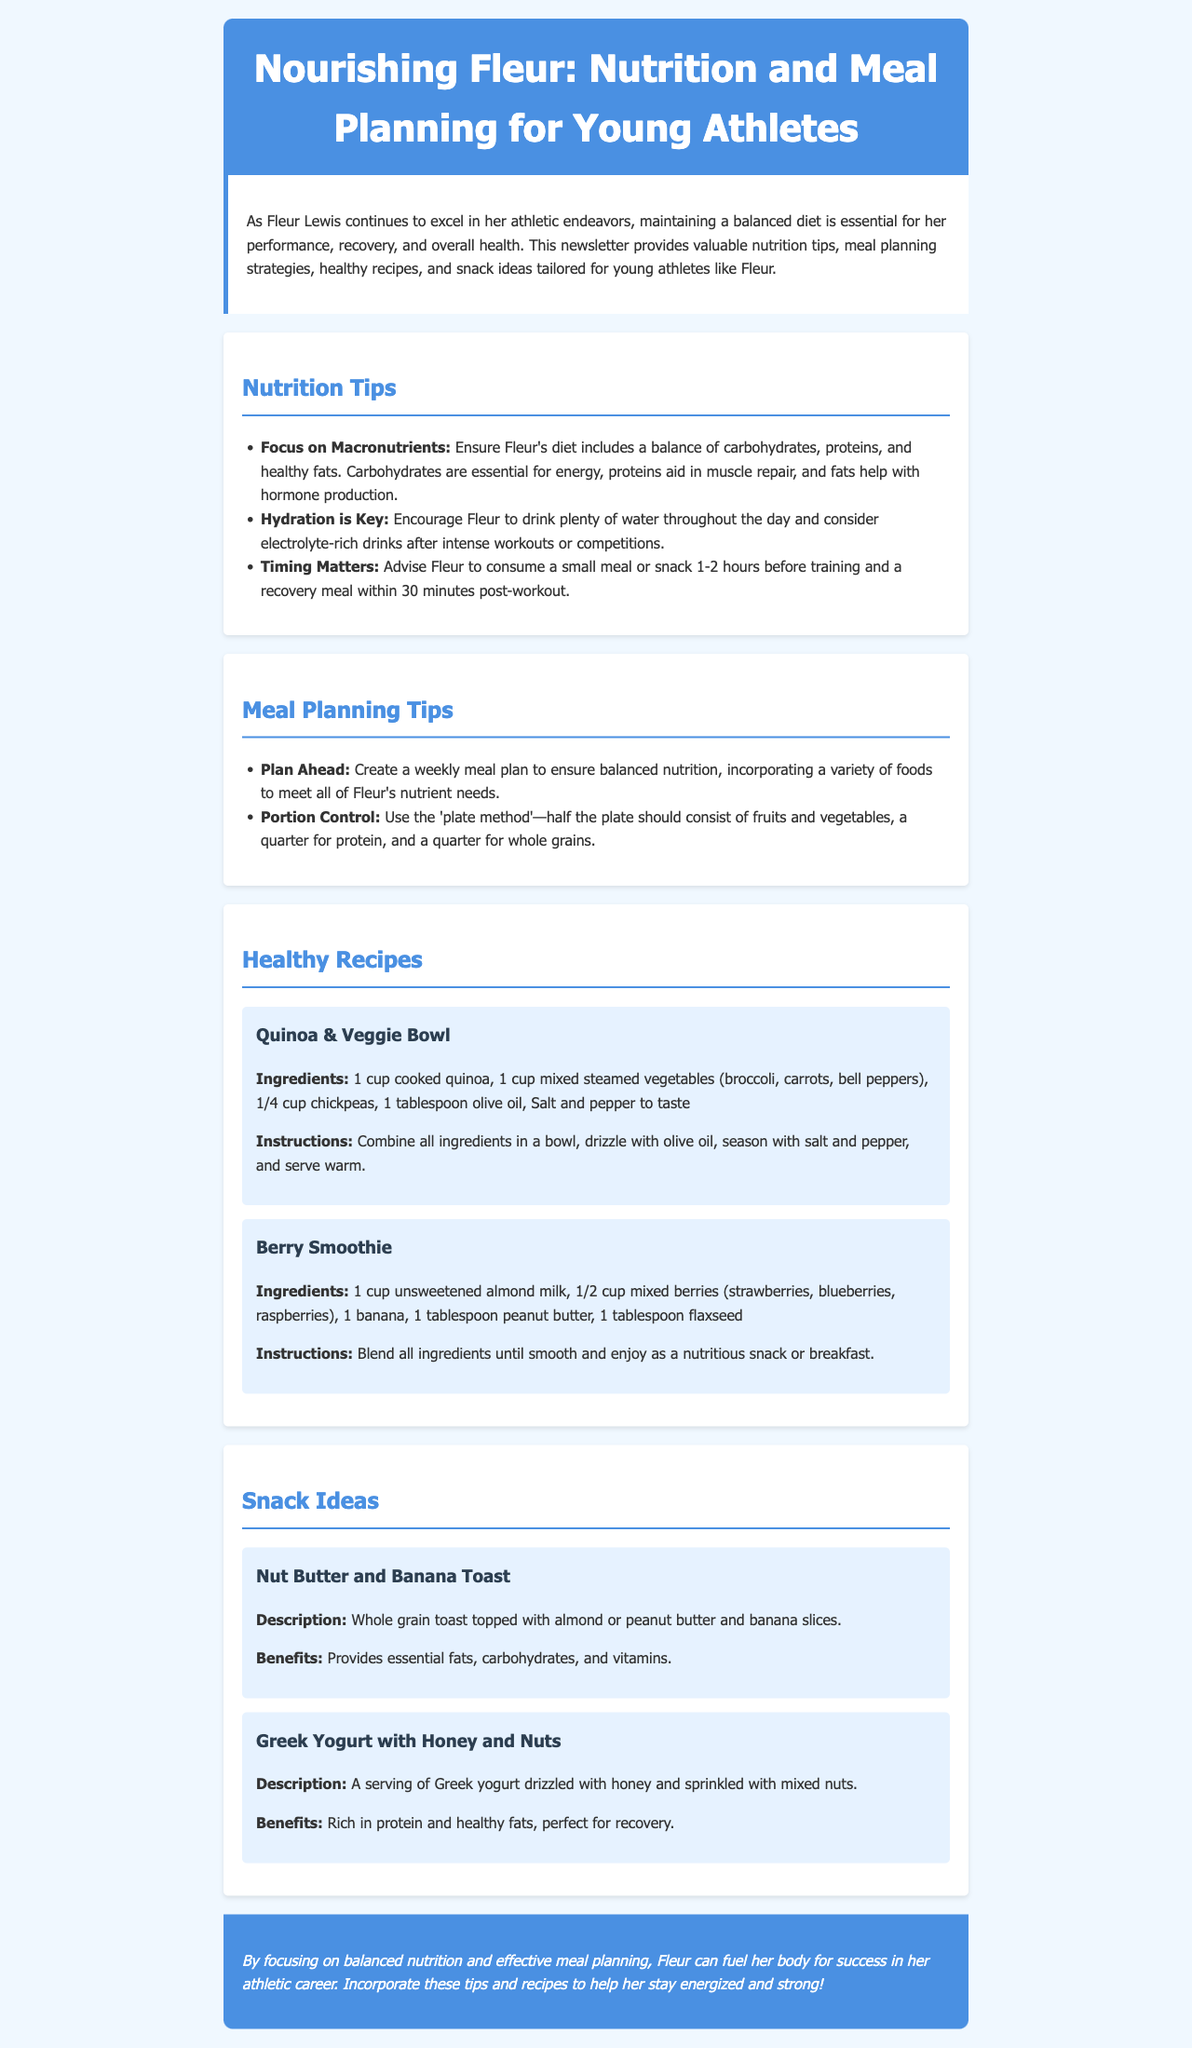What is the title of the newsletter? The title of the newsletter is displayed prominently at the top of the document, indicating the focus on Fleur's nutrition and meal planning.
Answer: Nourishing Fleur: Nutrition and Meal Planning for Young Athletes How many healthy recipes are provided? The document lists two healthy recipes under the Healthy Recipes section.
Answer: 2 What is a key component of Fleur's pre-training nutrition strategy? The text emphasizes the importance of consuming a small meal or snack before training to ensure energy and performance.
Answer: Small meal or snack 1-2 hours before training Which ingredient is used in both recipes? The recipes for Quinoa & Veggie Bowl and Berry Smoothie include an ingredient that helps provide essential nutrients for Fleur.
Answer: None What should half of Fleur's plate consist of according to the portion control guideline? The document advises that half the plate should be filled with fruits and vegetables as part of the portion control method.
Answer: Fruits and vegetables What is the benefit of Greek Yogurt with Honey and Nuts? The newsletter describes the nutritional advantages of this snack as being particularly beneficial for Fleur's recovery after workouts.
Answer: Rich in protein and healthy fats, perfect for recovery What cooking method is suggested for the vegetables in the Quinoa & Veggie Bowl? The recipe indicates preparing the vegetables using a method that retains their nutrients and enhances flavor.
Answer: Steamed What is Fleur's primary need for hydration after intense workouts? The document highlights the need for hydration and suggests a specific type of beverage for recovery.
Answer: Electrolyte-rich drinks 